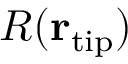Convert formula to latex. <formula><loc_0><loc_0><loc_500><loc_500>R ( { r } _ { t i p } )</formula> 